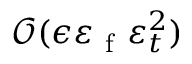Convert formula to latex. <formula><loc_0><loc_0><loc_500><loc_500>\mathcal { O } ( \epsilon \varepsilon _ { f } \varepsilon _ { t } ^ { 2 } )</formula> 